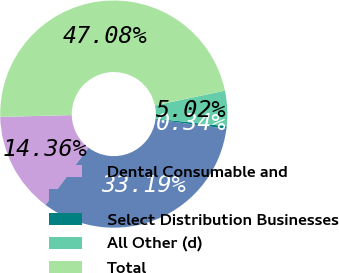Convert chart. <chart><loc_0><loc_0><loc_500><loc_500><pie_chart><fcel>Dental Consumable and<fcel>Unnamed: 1<fcel>Select Distribution Businesses<fcel>All Other (d)<fcel>Total<nl><fcel>14.36%<fcel>33.19%<fcel>0.34%<fcel>5.02%<fcel>47.08%<nl></chart> 